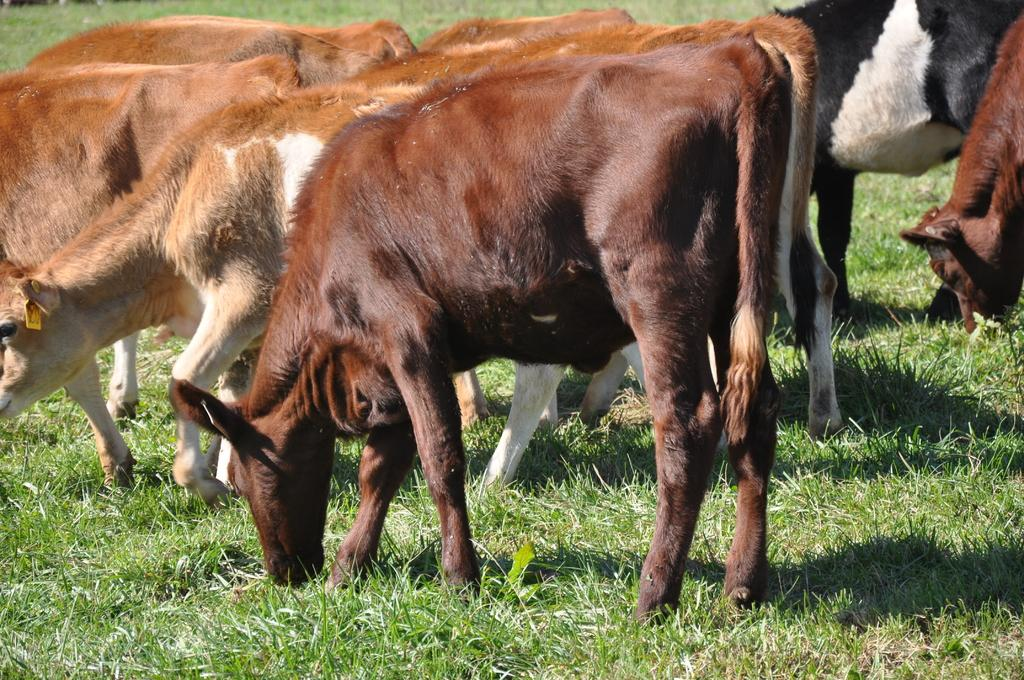What is the main subject of the image? There is a group of animals in the image. What are the animals doing in the image? The animals are eating grass. What type of environment is visible in the image? The grassy land is visible in the image. What type of skirt is the animal wearing in the image? There are no animals wearing skirts in the image; they are depicted as natural animals without clothing. 